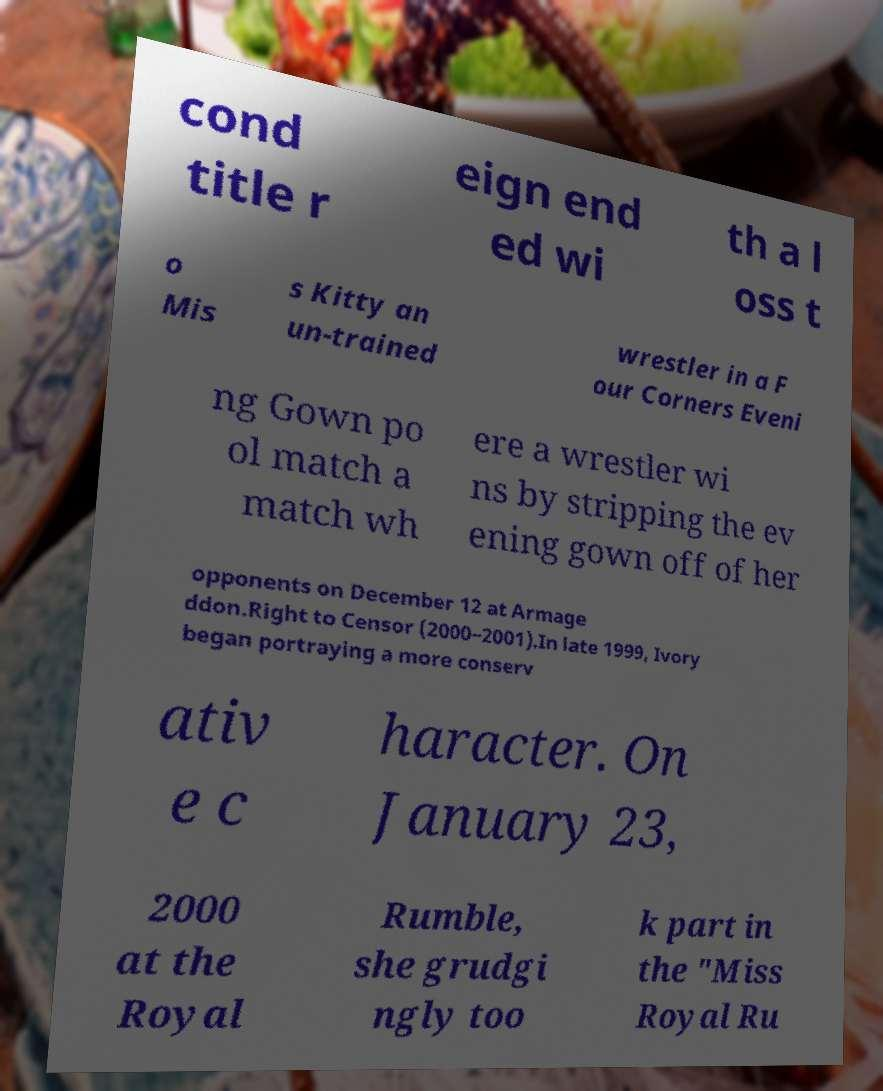Could you assist in decoding the text presented in this image and type it out clearly? cond title r eign end ed wi th a l oss t o Mis s Kitty an un-trained wrestler in a F our Corners Eveni ng Gown po ol match a match wh ere a wrestler wi ns by stripping the ev ening gown off of her opponents on December 12 at Armage ddon.Right to Censor (2000–2001).In late 1999, Ivory began portraying a more conserv ativ e c haracter. On January 23, 2000 at the Royal Rumble, she grudgi ngly too k part in the "Miss Royal Ru 